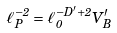Convert formula to latex. <formula><loc_0><loc_0><loc_500><loc_500>\ell _ { P } ^ { - 2 } = \ell _ { 0 } ^ { - D ^ { \prime } + 2 } V _ { B } ^ { \prime }</formula> 